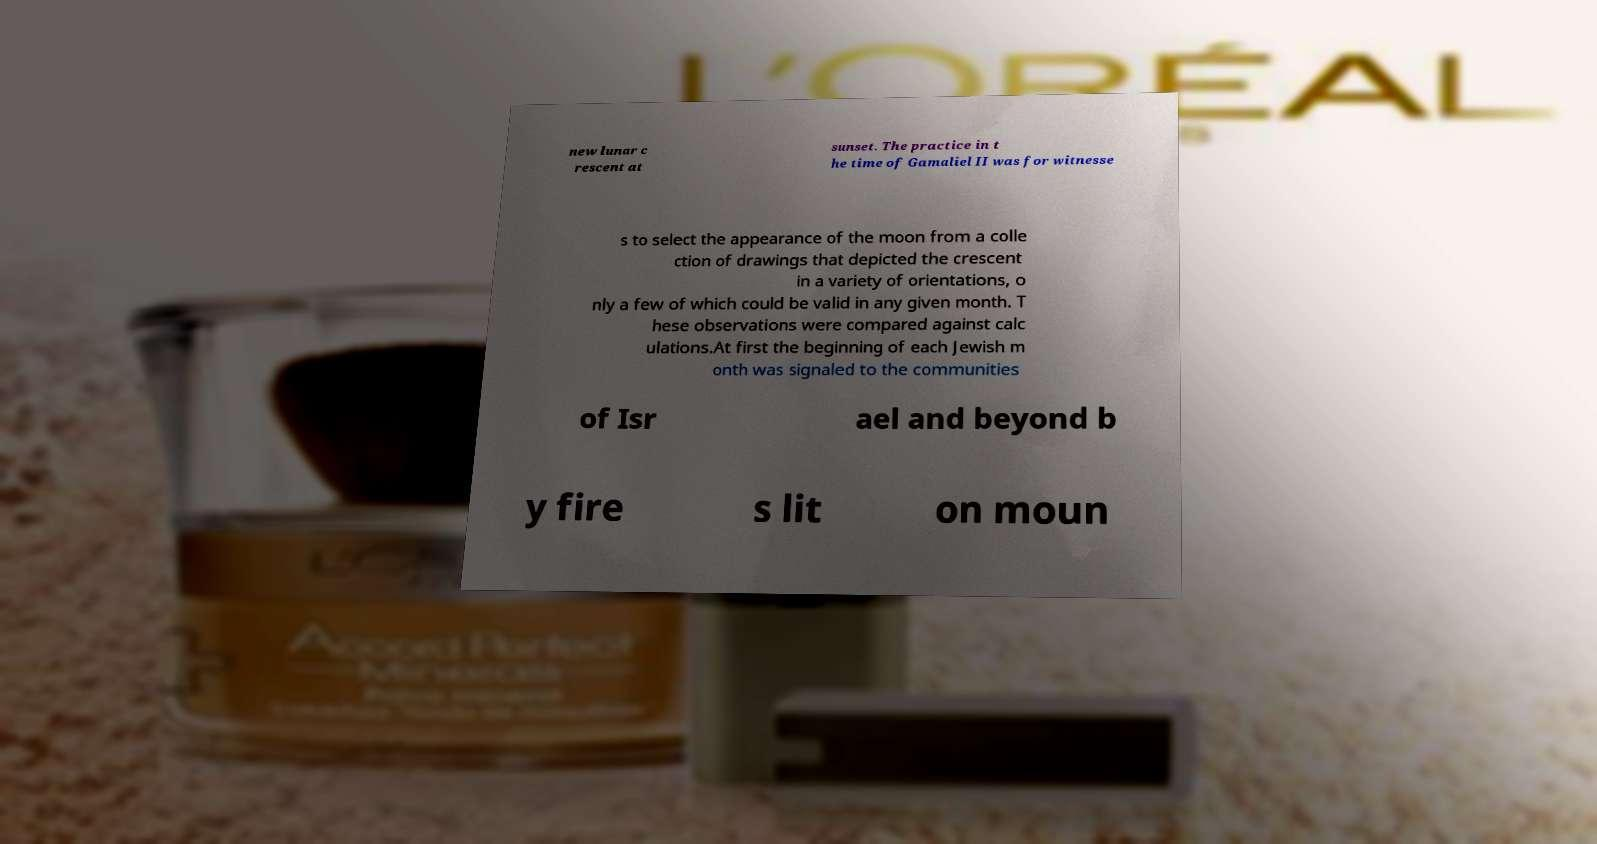I need the written content from this picture converted into text. Can you do that? new lunar c rescent at sunset. The practice in t he time of Gamaliel II was for witnesse s to select the appearance of the moon from a colle ction of drawings that depicted the crescent in a variety of orientations, o nly a few of which could be valid in any given month. T hese observations were compared against calc ulations.At first the beginning of each Jewish m onth was signaled to the communities of Isr ael and beyond b y fire s lit on moun 